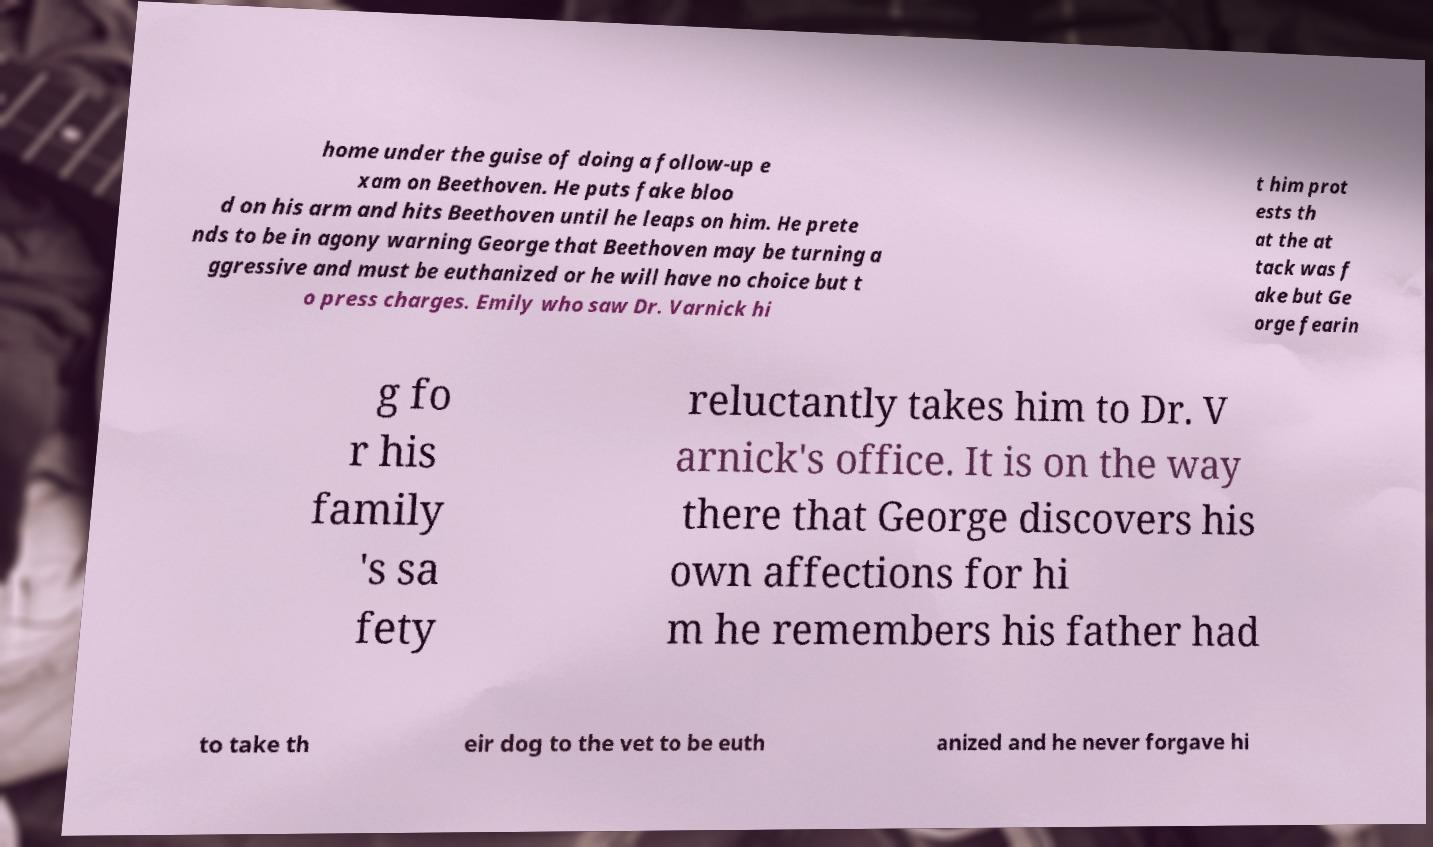Can you read and provide the text displayed in the image?This photo seems to have some interesting text. Can you extract and type it out for me? home under the guise of doing a follow-up e xam on Beethoven. He puts fake bloo d on his arm and hits Beethoven until he leaps on him. He prete nds to be in agony warning George that Beethoven may be turning a ggressive and must be euthanized or he will have no choice but t o press charges. Emily who saw Dr. Varnick hi t him prot ests th at the at tack was f ake but Ge orge fearin g fo r his family 's sa fety reluctantly takes him to Dr. V arnick's office. It is on the way there that George discovers his own affections for hi m he remembers his father had to take th eir dog to the vet to be euth anized and he never forgave hi 